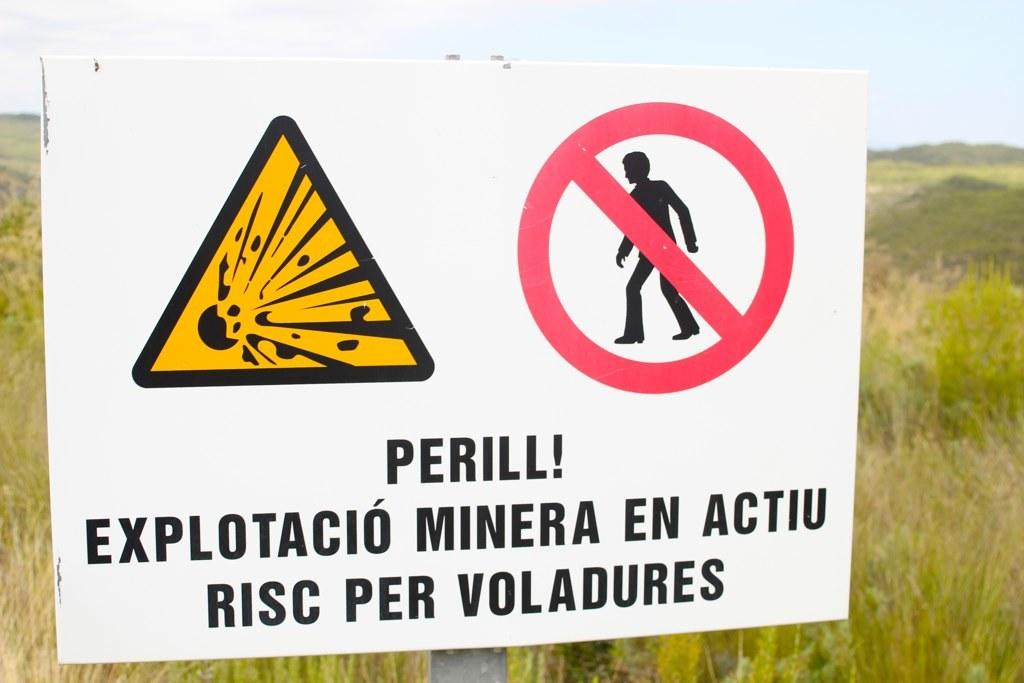Provide a one-sentence caption for the provided image. A sign showing a explosive potential with "Perill!" written on it. 